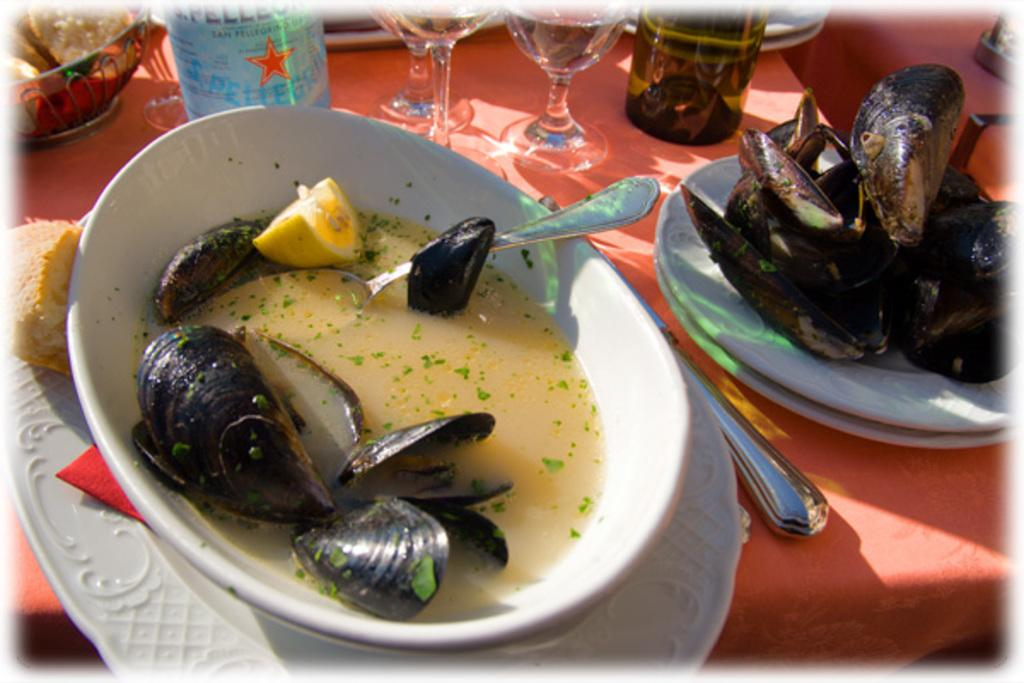What can be found on the table in the image? There are food items, wine glasses, and other utensils on the table. Can you describe the food items on the table? Unfortunately, the specific food items cannot be identified from the provided facts. What type of utensils are present on the table? The other utensils on the table cannot be identified from the provided facts. How many plants are on the bridge in the image? There is no bridge or plants present in the image. What type of bulb is used to light up the scene in the image? There is no mention of any bulbs or lighting in the provided facts. 